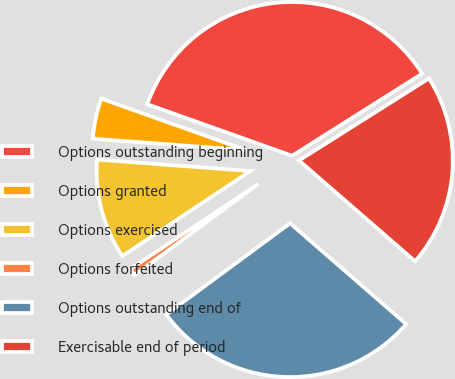Convert chart. <chart><loc_0><loc_0><loc_500><loc_500><pie_chart><fcel>Options outstanding beginning<fcel>Options granted<fcel>Options exercised<fcel>Options forfeited<fcel>Options outstanding end of<fcel>Exercisable end of period<nl><fcel>35.6%<fcel>4.25%<fcel>10.52%<fcel>0.77%<fcel>28.52%<fcel>20.34%<nl></chart> 